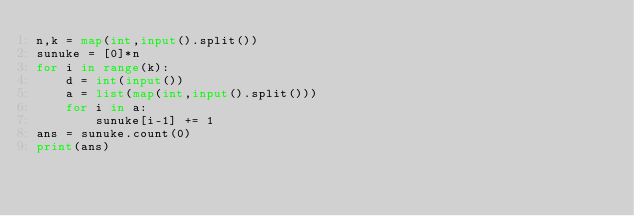<code> <loc_0><loc_0><loc_500><loc_500><_Python_>n,k = map(int,input().split())
sunuke = [0]*n
for i in range(k):
    d = int(input())
    a = list(map(int,input().split()))
    for i in a:
        sunuke[i-1] += 1
ans = sunuke.count(0)
print(ans)</code> 